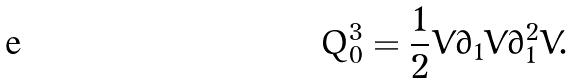<formula> <loc_0><loc_0><loc_500><loc_500>Q ^ { 3 } _ { 0 } = \frac { 1 } { 2 } V \partial _ { 1 } V \partial _ { 1 } ^ { 2 } V .</formula> 